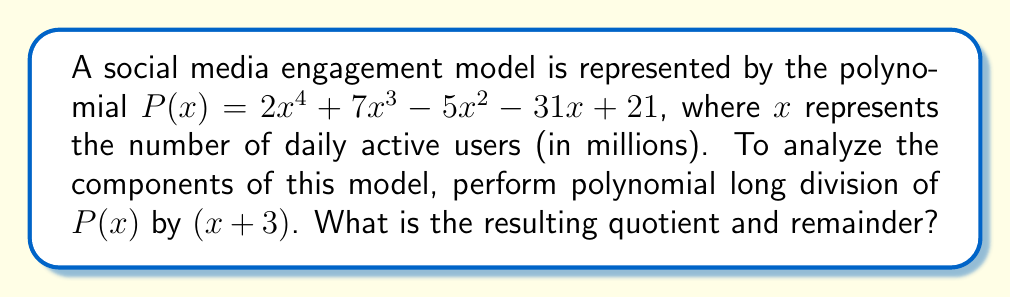Solve this math problem. Let's perform polynomial long division of $P(x)$ by $(x + 3)$:

$$
\begin{array}{r}
2x^3 + x^2 - 8x - 7 \\
x + 3 \enclose{longdiv}{2x^4 + 7x^3 - 5x^2 - 31x + 21} \\
\underline{2x^4 + 6x^3\phantom{xx}\:\:\:\:\:\:\:\:\:\:\:\:\:\:\:\:\:\:\:} \\
x^3 - 5x^2 - 31x + 21 \\
\underline{x^3 + 3x^2\phantom{xx}\:\:\:\:\:\:\:\:\:\:\:\:\:\:\:} \\
-8x^2 - 31x + 21 \\
\underline{-8x^2 - 24x\phantom{xx}\:\:\:\:\:\:} \\
-7x + 21 \\
\underline{-7x - 21} \\
42
\end{array}
$$

Step 1: Divide $2x^4$ by $x$ to get $2x^3$. Multiply $(x + 3)$ by $2x^3$ and subtract.
Step 2: Bring down the next term. Divide $x^3$ by $x$ to get $x^2$. Multiply $(x + 3)$ by $x^2$ and subtract.
Step 3: Bring down the next term. Divide $-8x^2$ by $x$ to get $-8x$. Multiply $(x + 3)$ by $-8x$ and subtract.
Step 4: Bring down the last term. Divide $-7x$ by $x$ to get $-7$. Multiply $(x + 3)$ by $-7$ and subtract.
Step 5: The process ends here as the degree of the remainder (42) is less than the degree of the divisor $(x + 3)$.

Therefore, the quotient is $2x^3 + x^2 - 8x - 7$ and the remainder is 42.
Answer: Quotient: $2x^3 + x^2 - 8x - 7$, Remainder: 42 